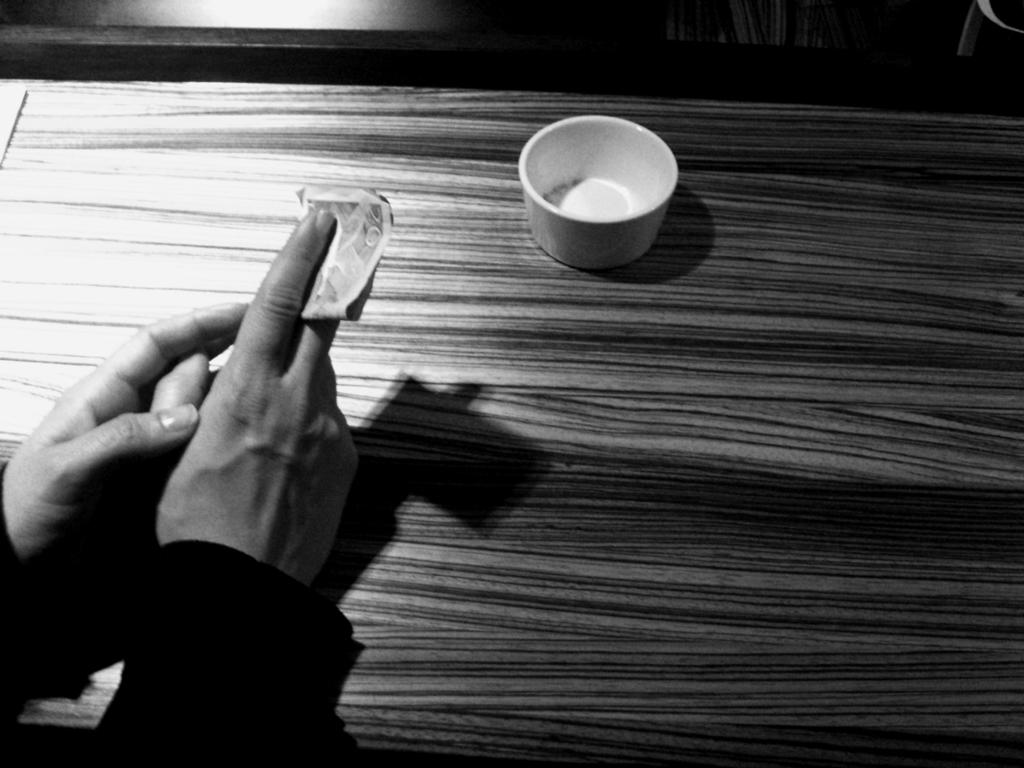What object is on the table in the image? There is a cup on the table in the image. What are the human hands doing in the image? The human hands are holding a paper in the image. What is the color scheme of the image? The image is black and white. What type of disease is being treated by the stone in the image? There is no stone or disease present in the image. How many bananas are visible in the image? There are no bananas present in the image. 